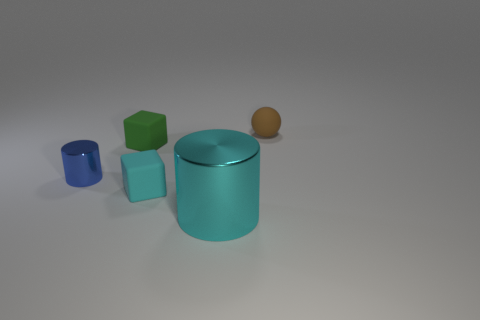Are there any other things that have the same size as the cyan cylinder?
Make the answer very short. No. There is a cyan object that is the same size as the blue thing; what shape is it?
Provide a short and direct response. Cube. Are there any other things of the same color as the sphere?
Provide a succinct answer. No. There is a brown sphere that is the same material as the green object; what is its size?
Keep it short and to the point. Small. Is the shape of the blue metal thing the same as the tiny thing that is in front of the small blue shiny thing?
Provide a short and direct response. No. How big is the cyan metal object?
Your answer should be very brief. Large. Are there fewer big cyan objects on the right side of the sphere than matte things?
Offer a very short reply. Yes. How many green cubes have the same size as the cyan matte cube?
Ensure brevity in your answer.  1. Do the cylinder to the right of the small green matte object and the shiny cylinder that is on the left side of the cyan metal cylinder have the same color?
Ensure brevity in your answer.  No. There is a small green rubber cube; how many shiny things are to the left of it?
Your response must be concise. 1. 